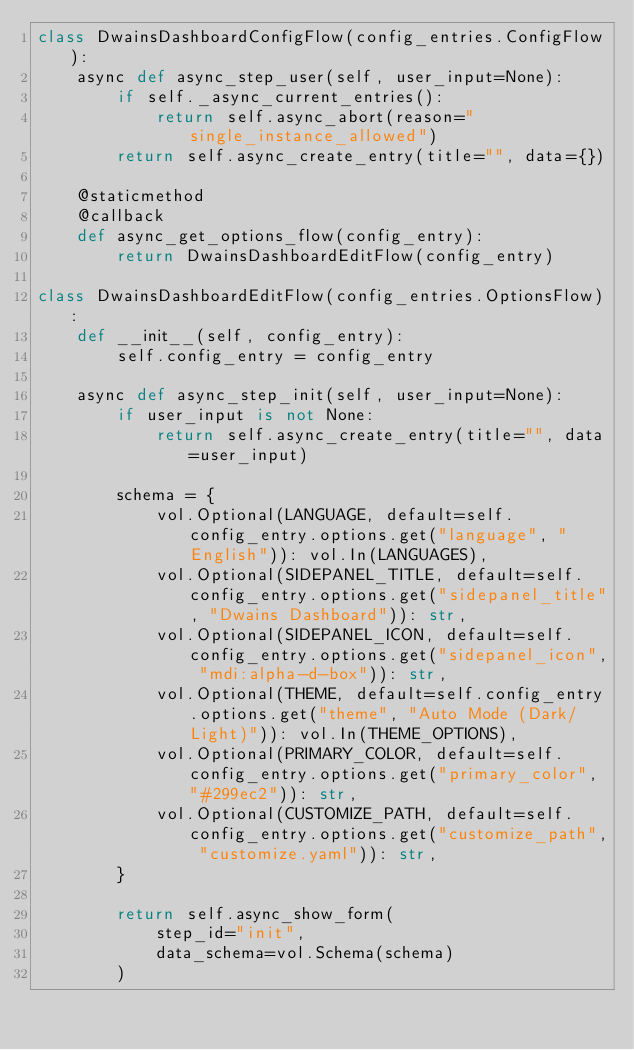Convert code to text. <code><loc_0><loc_0><loc_500><loc_500><_Python_>class DwainsDashboardConfigFlow(config_entries.ConfigFlow):
    async def async_step_user(self, user_input=None):
        if self._async_current_entries():
            return self.async_abort(reason="single_instance_allowed")
        return self.async_create_entry(title="", data={})

    @staticmethod
    @callback
    def async_get_options_flow(config_entry):
        return DwainsDashboardEditFlow(config_entry)

class DwainsDashboardEditFlow(config_entries.OptionsFlow):
    def __init__(self, config_entry):
        self.config_entry = config_entry

    async def async_step_init(self, user_input=None):
        if user_input is not None:
            return self.async_create_entry(title="", data=user_input)

        schema = {
            vol.Optional(LANGUAGE, default=self.config_entry.options.get("language", "English")): vol.In(LANGUAGES),
            vol.Optional(SIDEPANEL_TITLE, default=self.config_entry.options.get("sidepanel_title", "Dwains Dashboard")): str,
            vol.Optional(SIDEPANEL_ICON, default=self.config_entry.options.get("sidepanel_icon", "mdi:alpha-d-box")): str,
            vol.Optional(THEME, default=self.config_entry.options.get("theme", "Auto Mode (Dark/Light)")): vol.In(THEME_OPTIONS),
            vol.Optional(PRIMARY_COLOR, default=self.config_entry.options.get("primary_color", "#299ec2")): str,
            vol.Optional(CUSTOMIZE_PATH, default=self.config_entry.options.get("customize_path", "customize.yaml")): str,
        }

        return self.async_show_form(
            step_id="init",
            data_schema=vol.Schema(schema)
        )
</code> 